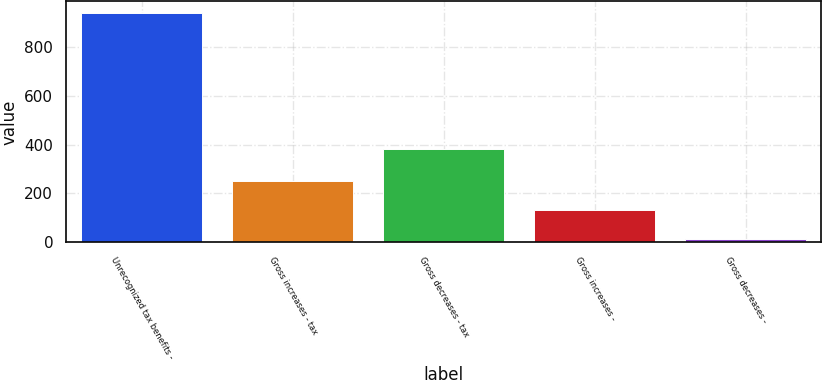Convert chart. <chart><loc_0><loc_0><loc_500><loc_500><bar_chart><fcel>Unrecognized tax benefits -<fcel>Gross increases - tax<fcel>Gross decreases - tax<fcel>Gross increases -<fcel>Gross decreases -<nl><fcel>939<fcel>251.6<fcel>383<fcel>133.3<fcel>15<nl></chart> 